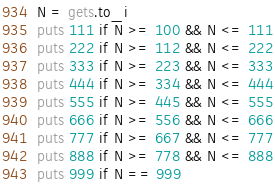Convert code to text. <code><loc_0><loc_0><loc_500><loc_500><_Ruby_>N = gets.to_i
puts 111 if N >= 100 && N <= 111
puts 222 if N >= 112 && N <= 222
puts 333 if N >= 223 && N <= 333
puts 444 if N >= 334 && N <= 444
puts 555 if N >= 445 && N <= 555
puts 666 if N >= 556 && N <= 666
puts 777 if N >= 667 && N <= 777
puts 888 if N >= 778 && N <= 888
puts 999 if N == 999</code> 